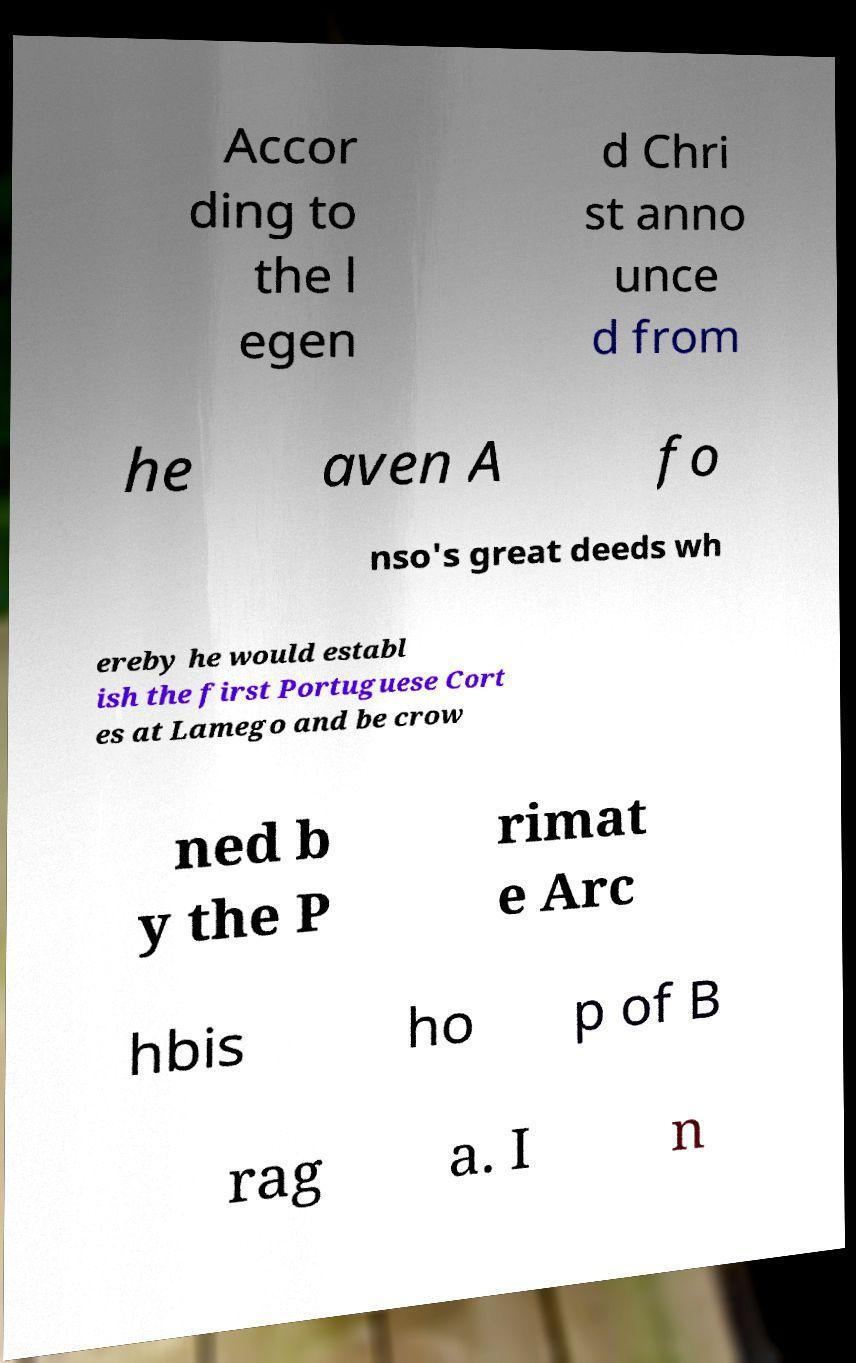Please identify and transcribe the text found in this image. Accor ding to the l egen d Chri st anno unce d from he aven A fo nso's great deeds wh ereby he would establ ish the first Portuguese Cort es at Lamego and be crow ned b y the P rimat e Arc hbis ho p of B rag a. I n 